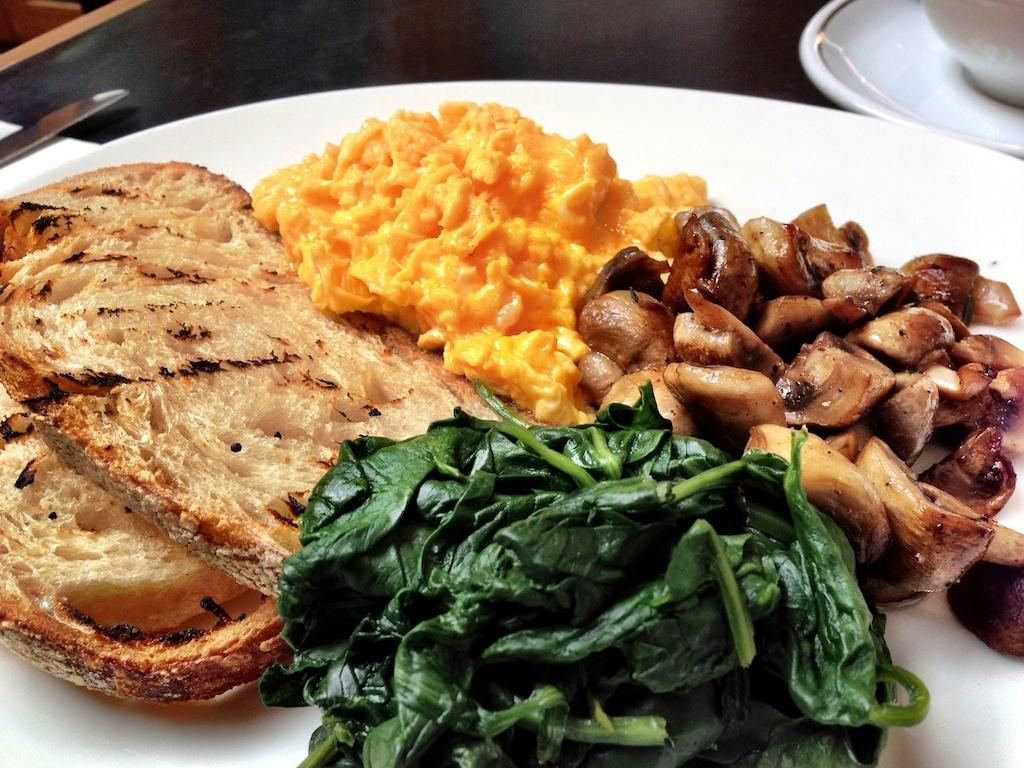What is on the white plate in the image? There are food items on the white plate in the image. What utensil is present in the image? There is a knife in the image. What is the cup used for in the image? The cup is used for holding a beverage or liquid. What is the saucer used for in the image? The saucer is used to hold the cup or to catch any spills. Where are all these items placed in the image? All of these items are placed on a table in the image. Reasoning: Let's think step by step by following the provided facts step by step to create the conversation. We start by identifying the main subject, which is the white plate with food items. Then, we mention the other items present in the image, such as the knife, cup, and saucer. We also describe their functions and where they are placed. Each question is designed to elicit a specific detail about the image that is known from the provided facts. Absurd Question/Answer: What type of border is visible on the floor in the image? There is no border visible on the floor in the image, as the facts provided do not mention a floor or any borders. 